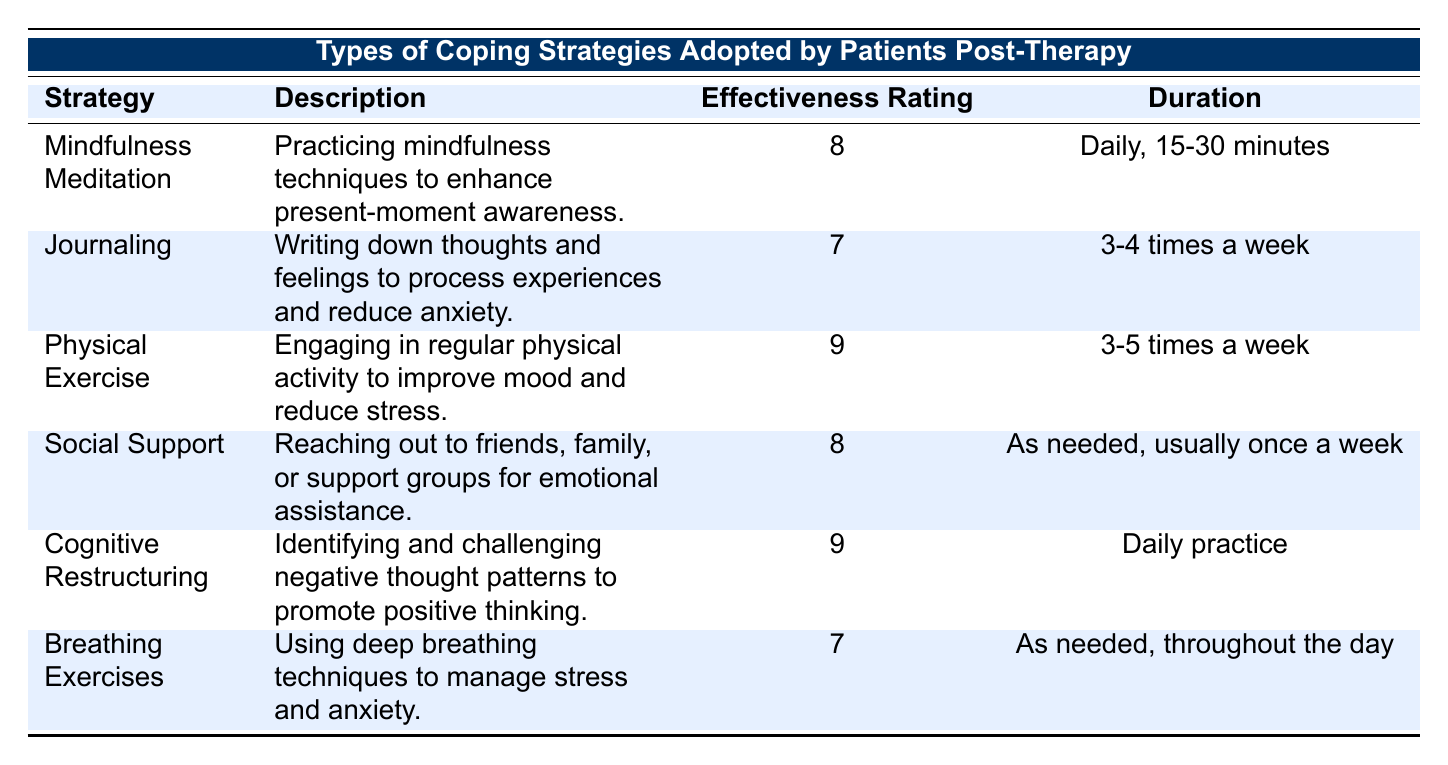What is the effectiveness rating of Physical Exercise? The table directly lists Physical Exercise under the Strategy column, where the corresponding Effectiveness Rating is provided. Upon checking, the Effectiveness Rating for Physical Exercise is 9.
Answer: 9 How often should someone practice Cognitive Restructuring? The Duration column specifies the recommended frequency for Cognitive Restructuring. It indicates that it should be practiced daily.
Answer: Daily practice Is Journaling rated as effective as Breathing Exercises? To answer this, I compare the Effectiveness Ratings of Journaling (7) and Breathing Exercises (7). They are equal, meaning Journaling is rated as effective as Breathing Exercises.
Answer: Yes What is the average effectiveness rating of the coping strategies listed? The Effectiveness Ratings are: 8, 7, 9, 8, 9, and 7. Summing these gives 8 + 7 + 9 + 8 + 9 + 7 = 48. There are 6 strategies, therefore the average effectiveness rating is 48/6 = 8.
Answer: 8 Does the strategy of Social Support require daily practice? The Duration for Social Support specifies that it is needed as necessary, typically once a week. This does not indicate daily practice.
Answer: No Which coping strategy has the highest effectiveness rating and what is its duration? Checking the Effectiveness Ratings, both Physical Exercise and Cognitive Restructuring have the highest rating of 9. Looking at their durations, Physical Exercise requires 3-5 times a week, while Cognitive Restructuring is done daily.
Answer: Physical Exercise; 3-5 times a week What are the two strategies that have an effectiveness rating of 8? From the table, the strategies with an effectiveness rating of 8 are Mindfulness Meditation and Social Support.
Answer: Mindfulness Meditation, Social Support How many coping strategies encourage physical activity at least three times a week? The table lists Physical Exercise, which is 3-5 times a week. There are no other strategies encouraging physical activity with that frequency. Therefore, the count is 1.
Answer: 1 